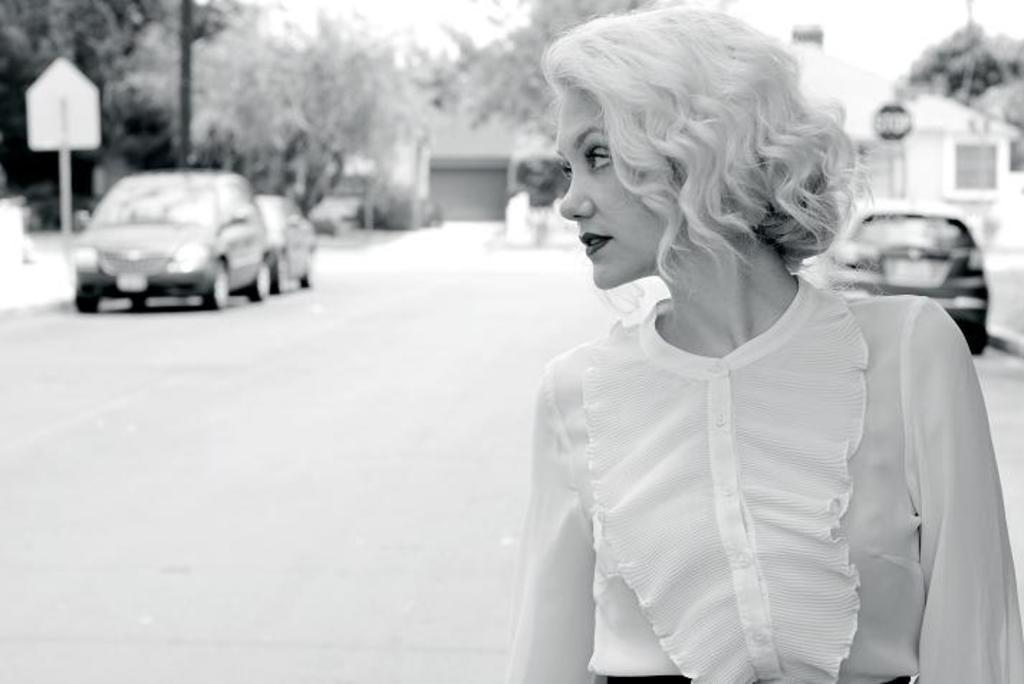Who is the main subject in the front of the image? There is a woman in the front of the image. What can be seen on the left side of the image? There are two cars on the left side of the image. What type of natural scenery is visible in the background of the image? There are trees in the background of the image. What object is visible in the image that might be used for displaying information or advertisements? There is a board visible in the image. What color scheme is used in the image? The image is black and white. How many airplanes can be seen flying in the background of the image? There are no airplanes visible in the image; it is a black and white image with a woman, cars, trees, and a board. What type of transportation is visible in the back of the image? There is no transportation visible in the back of the image; only trees are present in the background. 